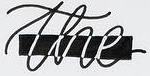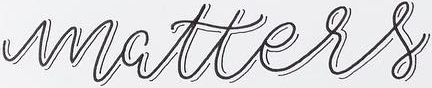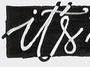Transcribe the words shown in these images in order, separated by a semicolon. the; matters; it's 